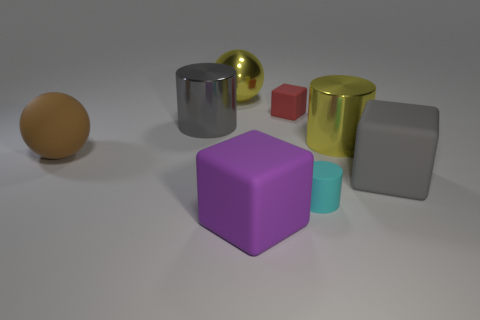Add 1 big metallic cylinders. How many objects exist? 9 Subtract all spheres. How many objects are left? 6 Add 4 big gray spheres. How many big gray spheres exist? 4 Subtract 0 red cylinders. How many objects are left? 8 Subtract all red shiny spheres. Subtract all small cylinders. How many objects are left? 7 Add 7 big yellow balls. How many big yellow balls are left? 8 